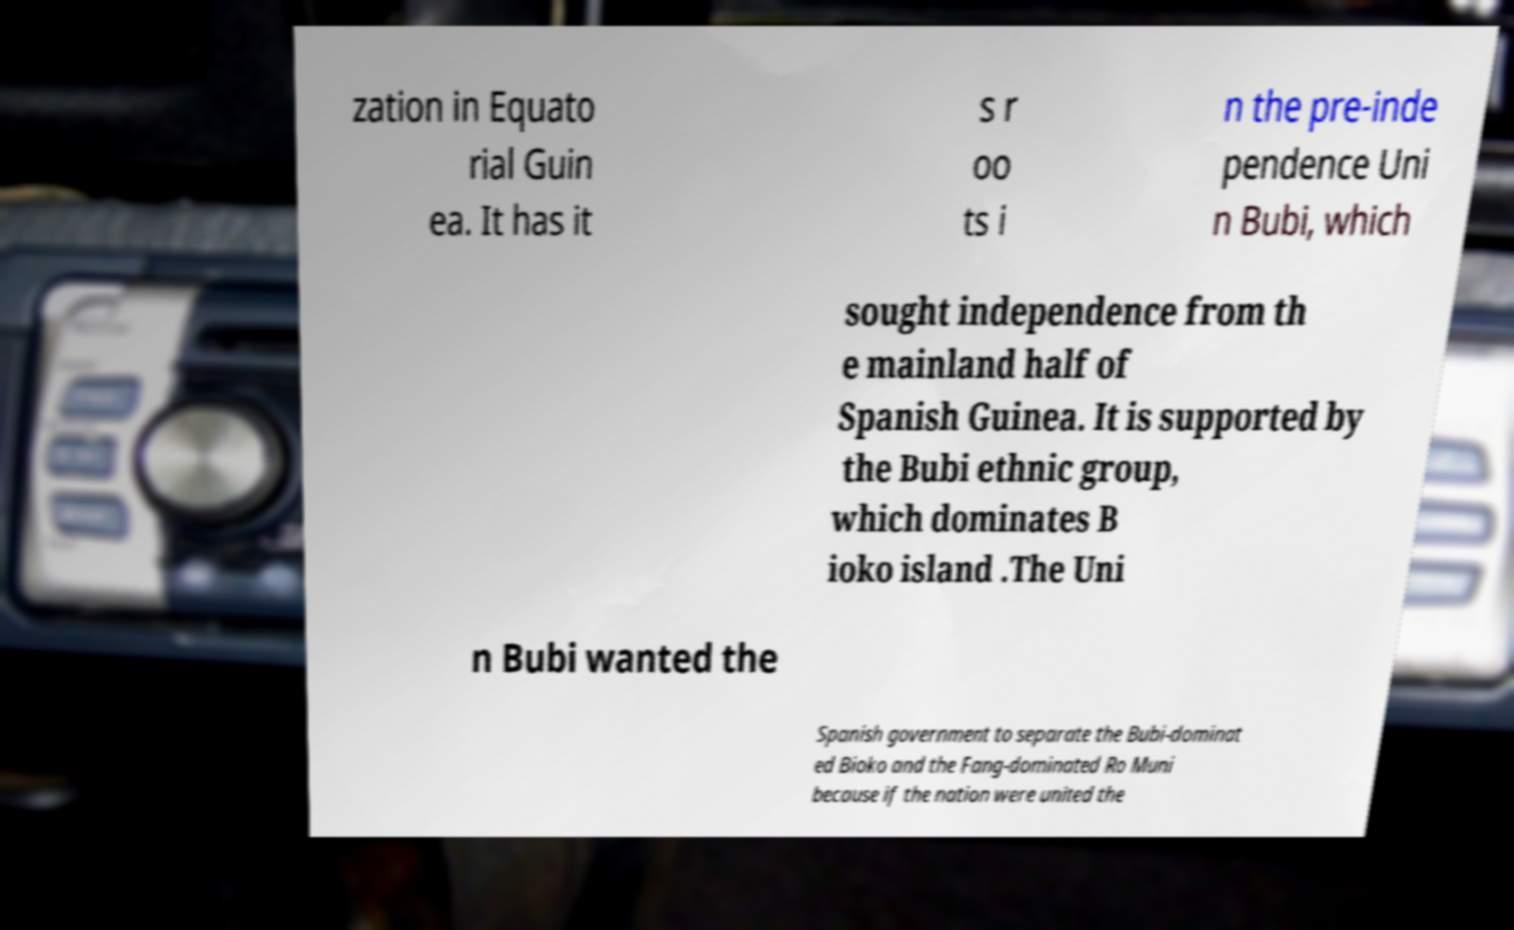Could you assist in decoding the text presented in this image and type it out clearly? zation in Equato rial Guin ea. It has it s r oo ts i n the pre-inde pendence Uni n Bubi, which sought independence from th e mainland half of Spanish Guinea. It is supported by the Bubi ethnic group, which dominates B ioko island .The Uni n Bubi wanted the Spanish government to separate the Bubi-dominat ed Bioko and the Fang-dominated Ro Muni because if the nation were united the 